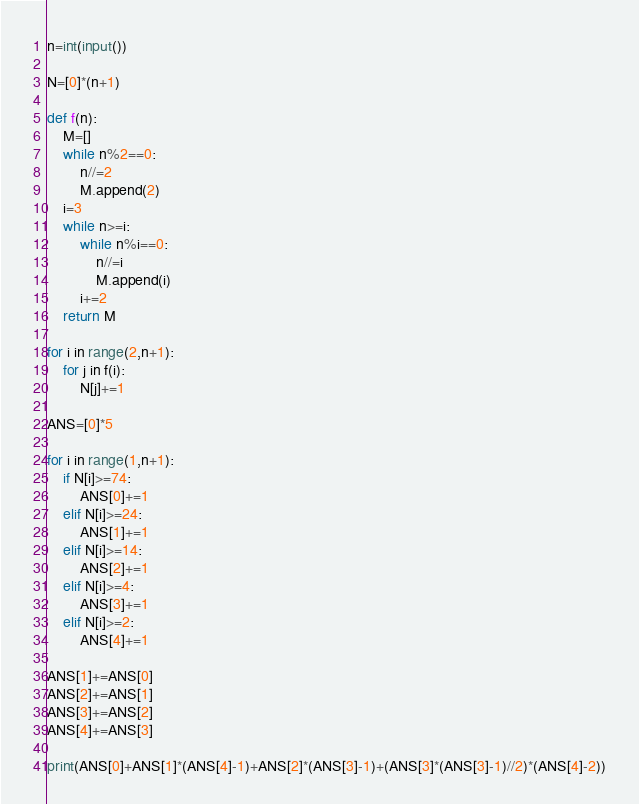Convert code to text. <code><loc_0><loc_0><loc_500><loc_500><_Python_>n=int(input())

N=[0]*(n+1)

def f(n):
    M=[]
    while n%2==0:
        n//=2
        M.append(2)
    i=3
    while n>=i:
        while n%i==0:
            n//=i
            M.append(i)
        i+=2
    return M

for i in range(2,n+1):
    for j in f(i):
        N[j]+=1

ANS=[0]*5

for i in range(1,n+1):
    if N[i]>=74:
        ANS[0]+=1
    elif N[i]>=24:
        ANS[1]+=1
    elif N[i]>=14:
        ANS[2]+=1
    elif N[i]>=4:
        ANS[3]+=1
    elif N[i]>=2:
        ANS[4]+=1

ANS[1]+=ANS[0]
ANS[2]+=ANS[1]
ANS[3]+=ANS[2]
ANS[4]+=ANS[3]

print(ANS[0]+ANS[1]*(ANS[4]-1)+ANS[2]*(ANS[3]-1)+(ANS[3]*(ANS[3]-1)//2)*(ANS[4]-2))</code> 